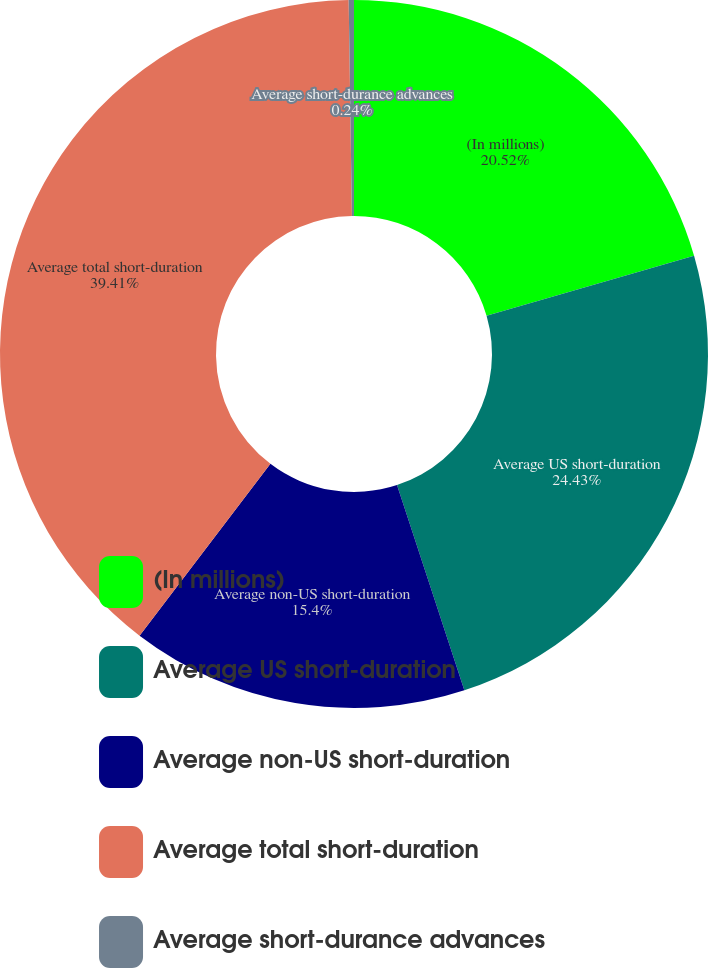Convert chart. <chart><loc_0><loc_0><loc_500><loc_500><pie_chart><fcel>(In millions)<fcel>Average US short-duration<fcel>Average non-US short-duration<fcel>Average total short-duration<fcel>Average short-durance advances<nl><fcel>20.52%<fcel>24.43%<fcel>15.4%<fcel>39.4%<fcel>0.24%<nl></chart> 